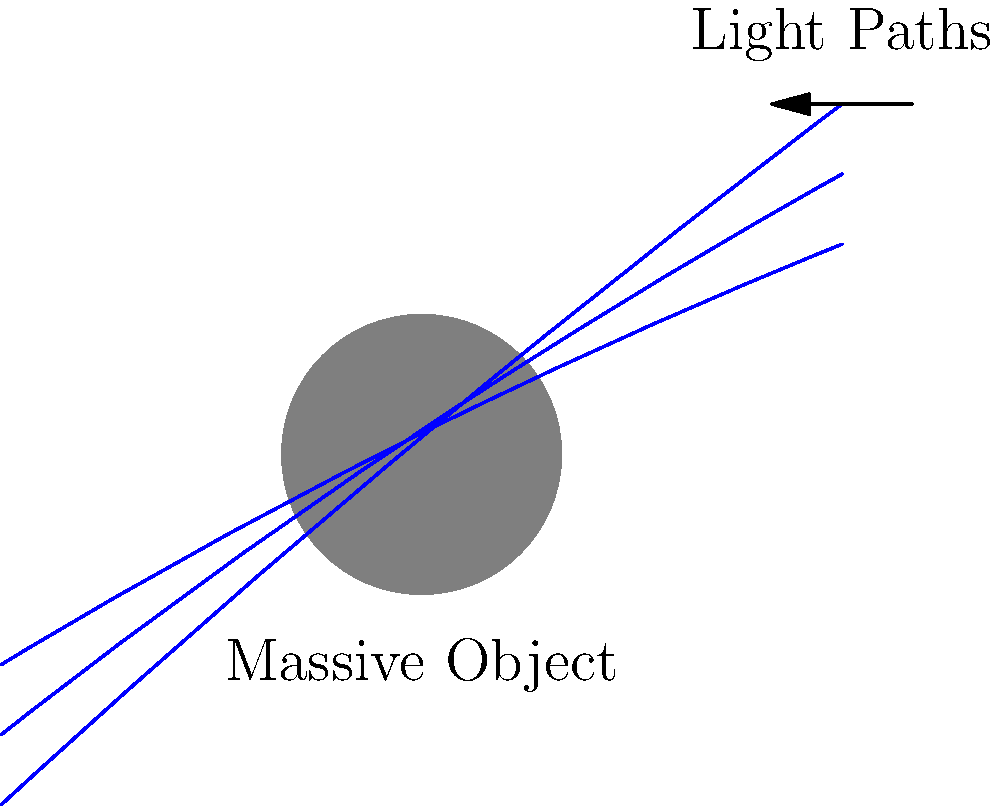In the diagram, light paths are shown bending around a massive object. This phenomenon is known as gravitational lensing. Based on your understanding of this concept, what would happen to the apparent position of a distant light source located directly behind the massive object from an observer's perspective? Let's break this down step-by-step:

1. Gravitational lensing occurs when the gravity of a massive object bends the path of light from a distant source.

2. In the diagram, we see light paths bending around the massive object. This bending is more pronounced for light paths that pass closer to the object.

3. For a light source directly behind the massive object:
   a) Light rays from the source would be bent symmetrically around the object.
   b) These bent light rays would reach the observer from slightly different angles than if the massive object weren't there.

4. The observer's brain interprets light rays coming from different angles as originating from different positions in space.

5. In this case, the symmetrically bent light rays would create the illusion of a ring of light around the massive object. This is known as an "Einstein ring."

6. The original light source isn't visible directly, as its light is blocked by the massive object. Instead, its image appears as a ring surrounding the massive object.

7. This effect can sometimes create multiple images of the same light source, depending on the alignment and mass distribution of the lensing object.

Therefore, the apparent position of the light source would not be its true position behind the massive object, but rather a ring-like image surrounding the massive object.
Answer: Einstein ring 